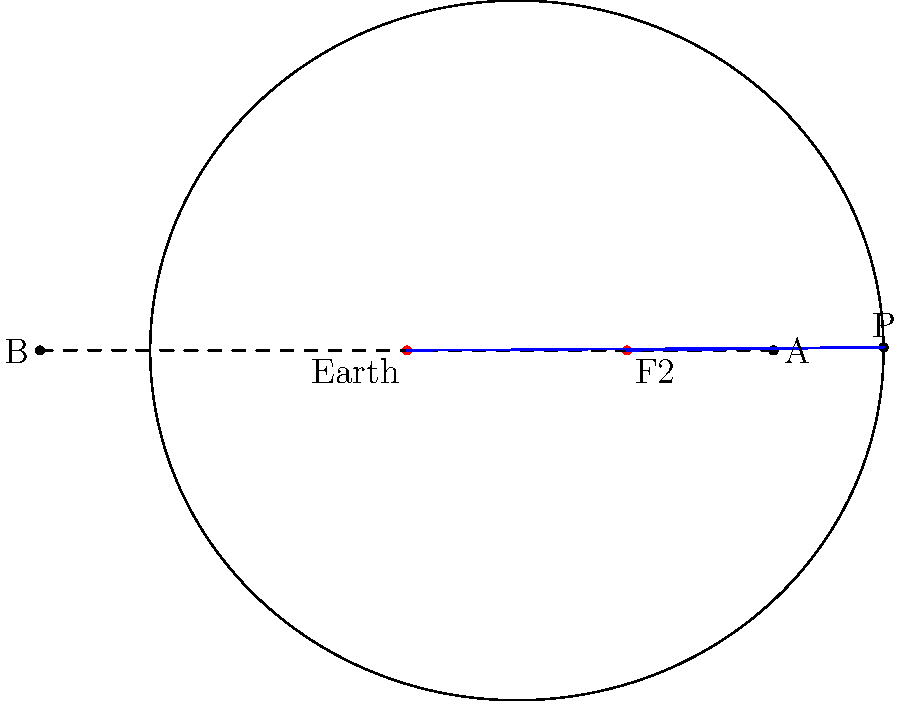Consider a satellite orbiting Earth in an elliptical path as shown in the diagram. The Earth is located at one focus (F1) of the ellipse. Given that the semi-major axis $a = 2.5$ units and the distance between the foci is 1.5 units, calculate the eccentricity $e$ of the orbit. How does this value relate to the shape of the orbit? To solve this problem, let's follow these steps:

1) The eccentricity $e$ of an ellipse is defined as the ratio of the distance between the foci to the length of the major axis. In mathematical terms:

   $e = \frac{c}{a}$

   where $c$ is half the distance between the foci, and $a$ is the semi-major axis.

2) We're given that the semi-major axis $a = 2.5$ units.

3) The distance between the foci is 1.5 units, so $c = 1.5/2 = 0.75$ units.

4) Now we can calculate the eccentricity:

   $e = \frac{c}{a} = \frac{0.75}{2.5} = 0.3$

5) Regarding the shape of the orbit:
   - Eccentricity ranges from 0 to 1 for ellipses.
   - $e = 0$ represents a circle (special case of an ellipse).
   - As $e$ approaches 1, the ellipse becomes more elongated.

6) With $e = 0.3$, this orbit is moderately elliptical. It's not circular ($e \neq 0$), but it's also not extremely elongated (as $e$ is closer to 0 than to 1).

This eccentricity indicates a stable elliptical orbit, common for many artificial satellites and natural celestial bodies in the solar system.
Answer: $e = 0.3$; moderately elliptical orbit 